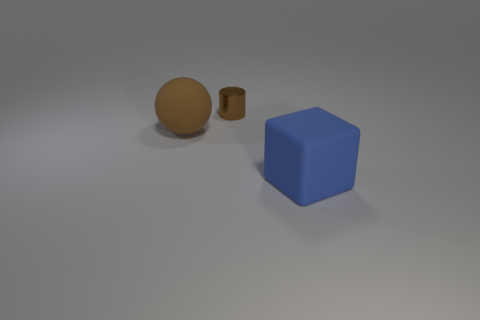What color is the cube that is the same material as the large brown ball? blue 